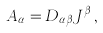<formula> <loc_0><loc_0><loc_500><loc_500>A _ { \alpha } = D _ { \alpha \beta } J ^ { \beta } \, ,</formula> 